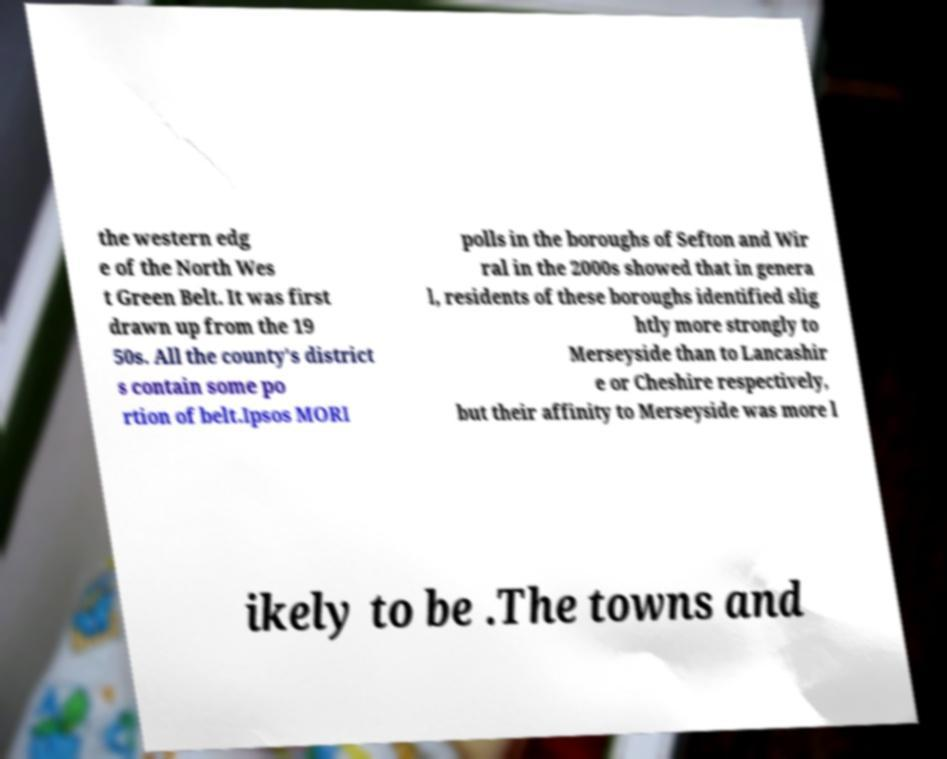Could you assist in decoding the text presented in this image and type it out clearly? the western edg e of the North Wes t Green Belt. It was first drawn up from the 19 50s. All the county's district s contain some po rtion of belt.Ipsos MORI polls in the boroughs of Sefton and Wir ral in the 2000s showed that in genera l, residents of these boroughs identified slig htly more strongly to Merseyside than to Lancashir e or Cheshire respectively, but their affinity to Merseyside was more l ikely to be .The towns and 